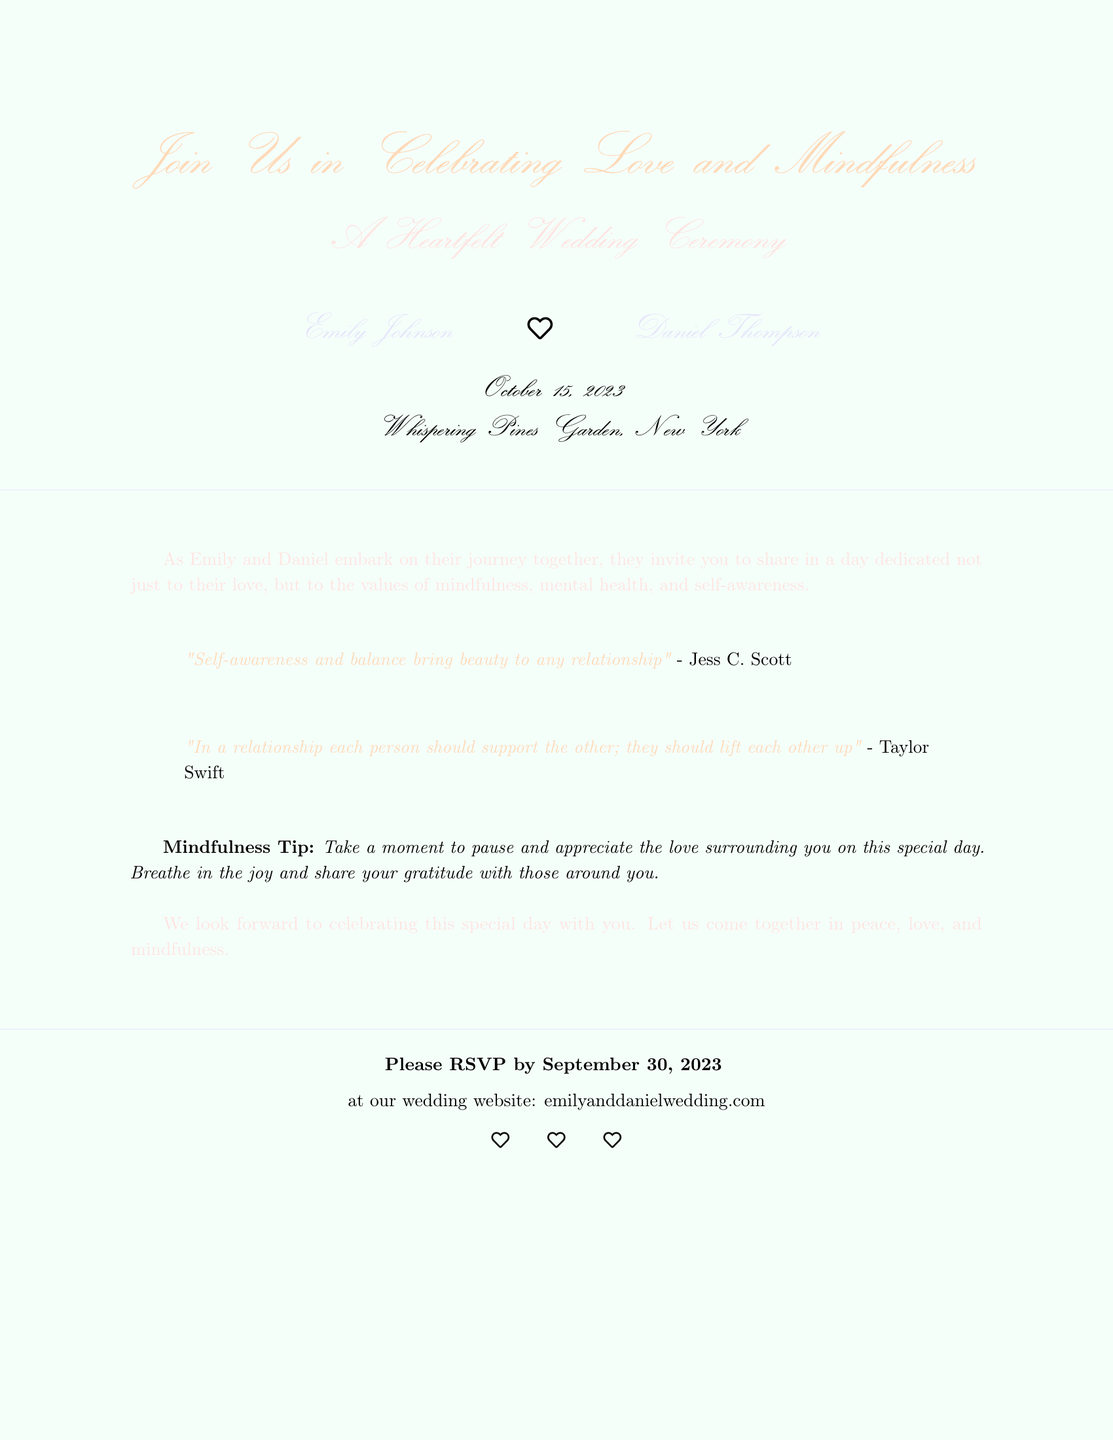What is the date of the wedding ceremony? The date is clearly stated in the invitation portion of the document.
Answer: October 15, 2023 Who are the individuals getting married? The names of the couple are prominently displayed in the invitation.
Answer: Emily Johnson and Daniel Thompson Where is the wedding ceremony taking place? The location of the wedding is mentioned in the details section.
Answer: Whispering Pines Garden, New York What is the RSVP deadline? The document provides a specific date for the RSVP.
Answer: September 30, 2023 What mindfulness tip is included in the invitation? The invitation features a specific mindfulness tip aimed at guests.
Answer: Take a moment to pause and appreciate the love surrounding you on this special day What color is used for the background of the invitation? The background color is specified in the document and contributes to its design.
Answer: Mint green What theme does this wedding invitation emphasize? The invitation's text highlights the overall theme that the couple wants to convey.
Answer: Mindfulness and mental health What quotes are provided regarding relationships? The document includes specific quotes that emphasize the importance of self-awareness and support in relationships.
Answer: "Self-awareness and balance bring beauty to any relationship" - Jess C. Scott and "In a relationship each person should support the other; they should lift each other up" - Taylor Swift 